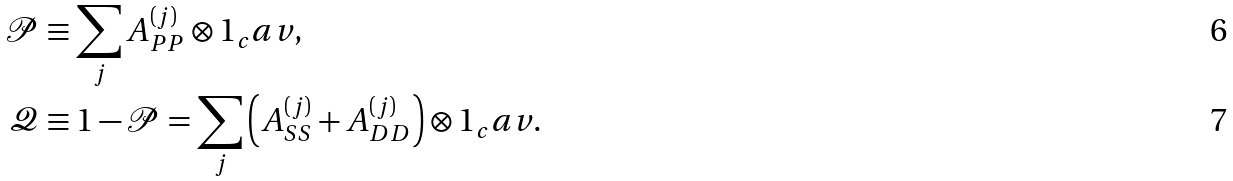<formula> <loc_0><loc_0><loc_500><loc_500>\mathcal { P } & \equiv \sum _ { j } A _ { P P } ^ { ( j ) } \otimes 1 _ { c } a v , \\ \mathcal { Q } & \equiv 1 - \mathcal { P } = \sum _ { j } \left ( A _ { S S } ^ { ( j ) } + A _ { D D } ^ { ( j ) } \right ) \otimes 1 _ { c } a v .</formula> 